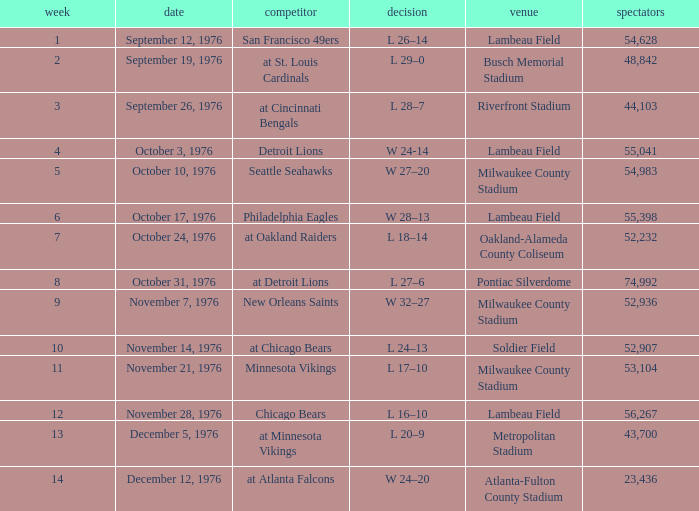How many people attended the game on September 19, 1976? 1.0. 